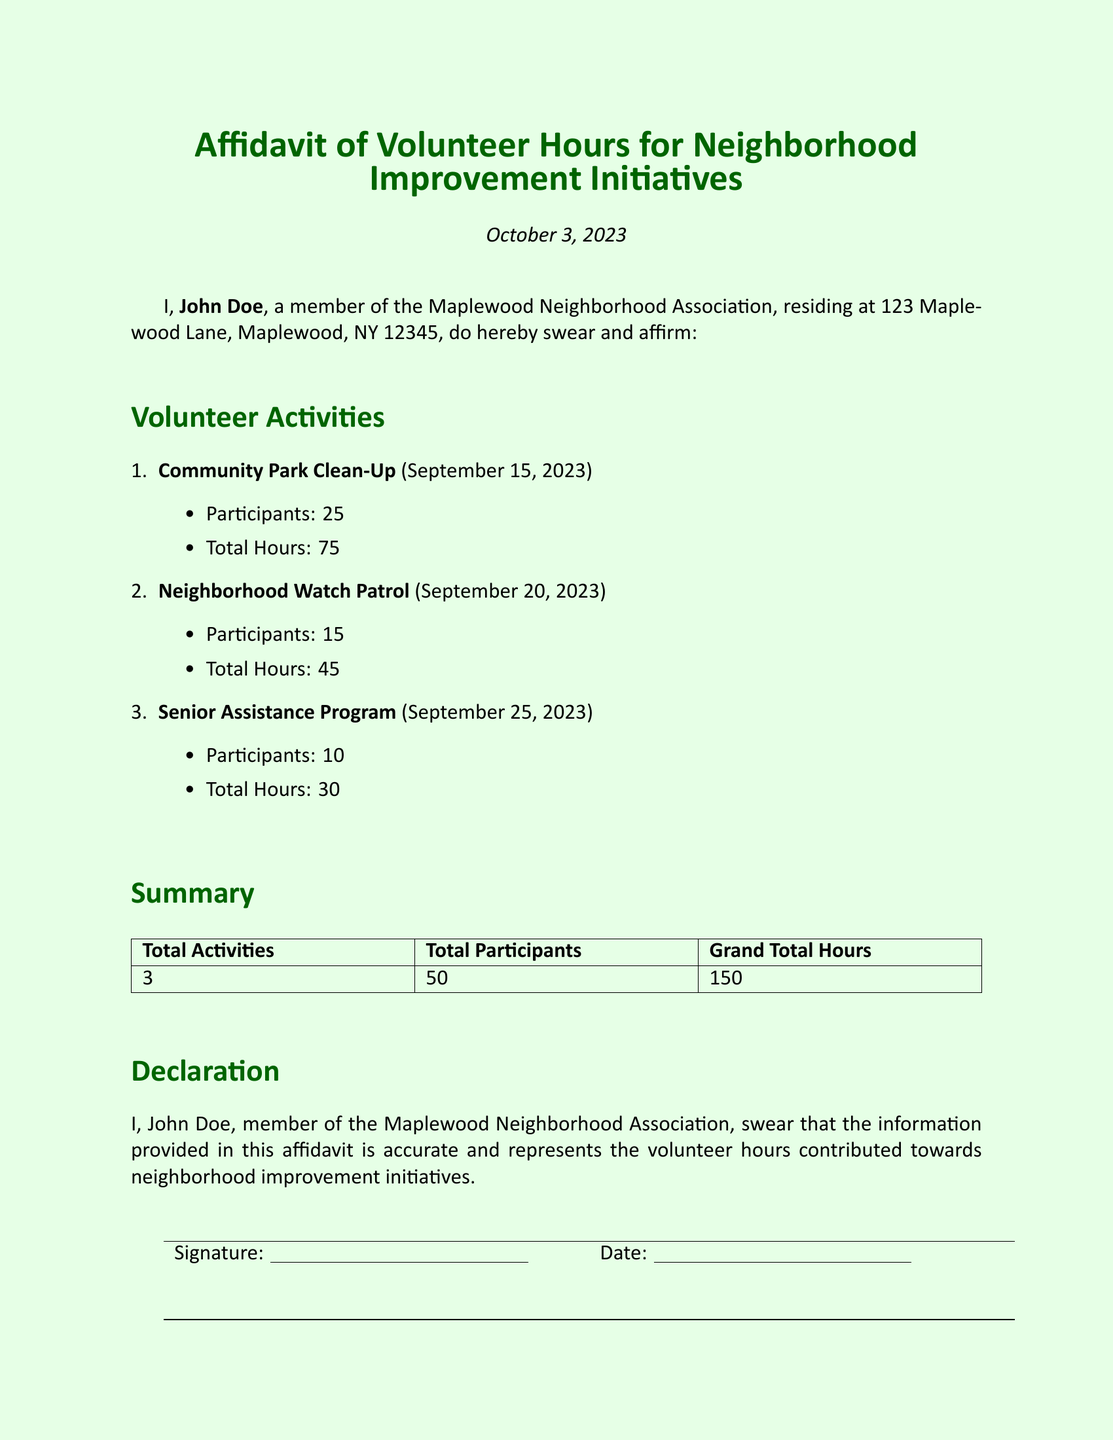What is the name of the person swearing the affidavit? The name of the individual is stated in the introduction section of the document.
Answer: John Doe What is the date of the affidavit? The date is mentioned at the top of the document.
Answer: October 3, 2023 How many participants were involved in the Community Park Clean-Up? This information is listed under the activity details for that event.
Answer: 25 What is the total number of volunteer hours contributed for all activities? The grand total hours is calculated and stated in the summary section.
Answer: 150 Which program had the least number of participants? This requires comparing participant numbers across the activities listed.
Answer: Senior Assistance Program How many total activities are reported? This is found in the summary table listing the total activities.
Answer: 3 What type of initiative is John Doe affiliated with? The affiliation is mentioned in the introduction of the affidavit.
Answer: Maplewood Neighborhood Association What is the total number of participants for the Neighborhood Watch Patrol? This information is included in the activity details for that specific event.
Answer: 15 Which activity took place on September 25, 2023? This requires recalling the date mentioned alongside the activity names.
Answer: Senior Assistance Program 